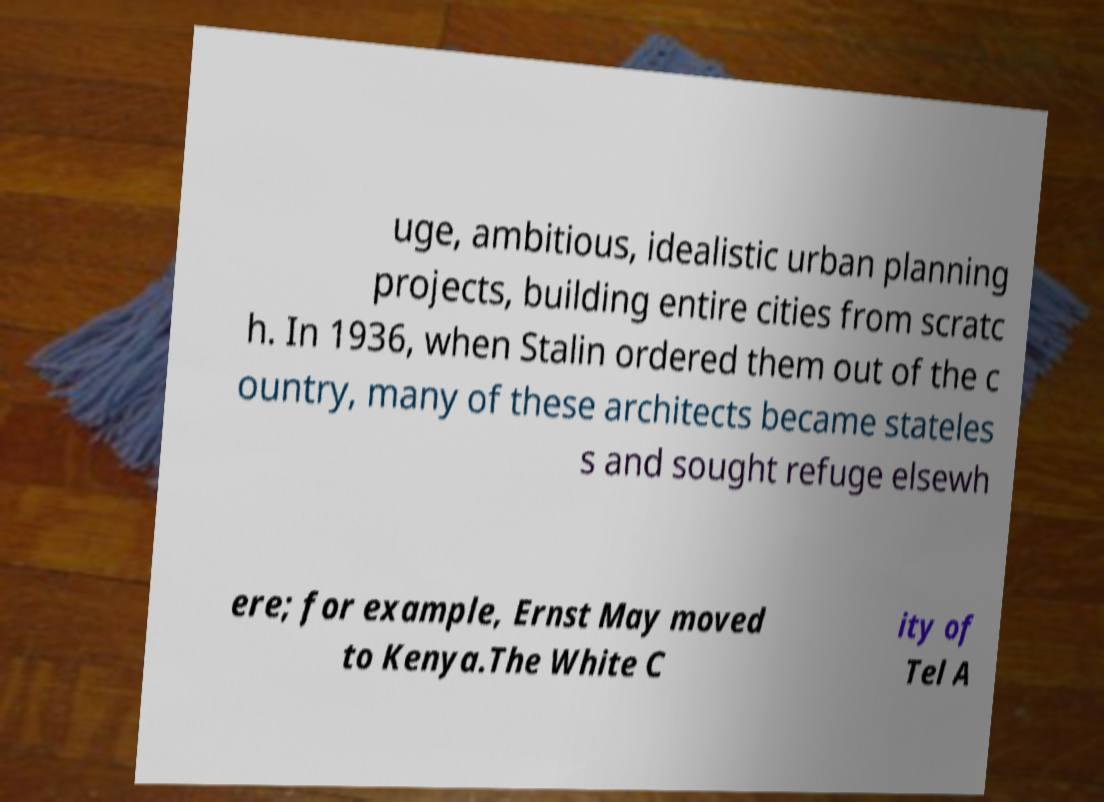Please identify and transcribe the text found in this image. uge, ambitious, idealistic urban planning projects, building entire cities from scratc h. In 1936, when Stalin ordered them out of the c ountry, many of these architects became stateles s and sought refuge elsewh ere; for example, Ernst May moved to Kenya.The White C ity of Tel A 